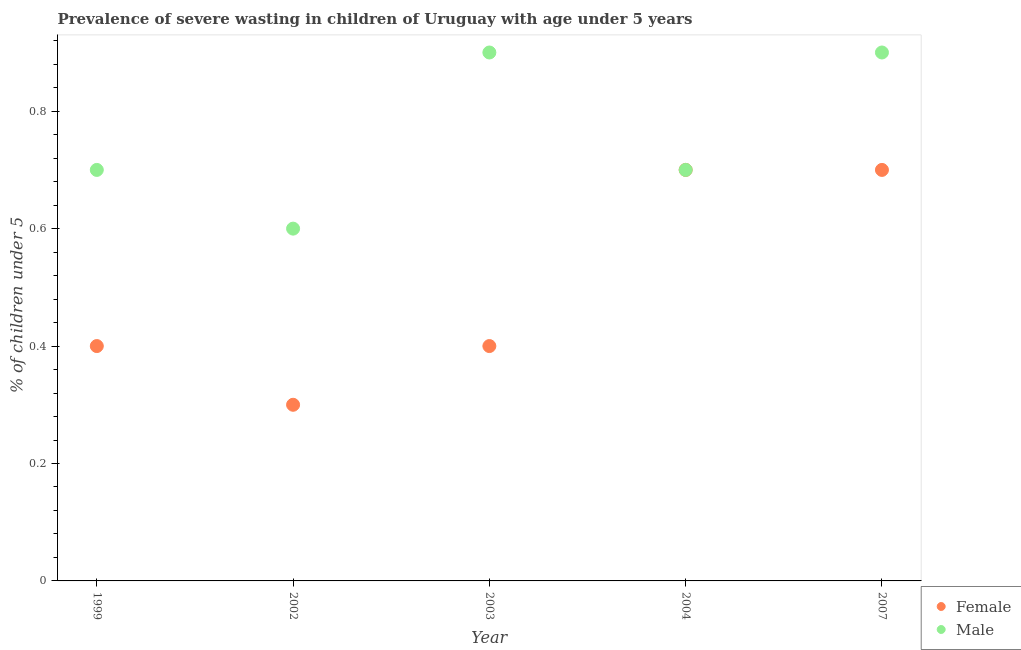What is the percentage of undernourished female children in 2007?
Your response must be concise. 0.7. Across all years, what is the maximum percentage of undernourished male children?
Your response must be concise. 0.9. Across all years, what is the minimum percentage of undernourished female children?
Give a very brief answer. 0.3. In which year was the percentage of undernourished male children maximum?
Provide a succinct answer. 2003. In which year was the percentage of undernourished male children minimum?
Your response must be concise. 2002. What is the total percentage of undernourished male children in the graph?
Your response must be concise. 3.8. What is the difference between the percentage of undernourished male children in 1999 and that in 2004?
Keep it short and to the point. 0. What is the difference between the percentage of undernourished female children in 2007 and the percentage of undernourished male children in 2004?
Make the answer very short. 0. What is the average percentage of undernourished male children per year?
Provide a short and direct response. 0.76. In the year 2007, what is the difference between the percentage of undernourished female children and percentage of undernourished male children?
Your answer should be very brief. -0.2. What is the ratio of the percentage of undernourished male children in 1999 to that in 2007?
Provide a short and direct response. 0.78. Is the percentage of undernourished female children in 1999 less than that in 2002?
Offer a very short reply. No. What is the difference between the highest and the lowest percentage of undernourished male children?
Your answer should be very brief. 0.3. In how many years, is the percentage of undernourished female children greater than the average percentage of undernourished female children taken over all years?
Make the answer very short. 2. Is the sum of the percentage of undernourished male children in 2002 and 2004 greater than the maximum percentage of undernourished female children across all years?
Keep it short and to the point. Yes. Does the percentage of undernourished female children monotonically increase over the years?
Provide a short and direct response. No. Is the percentage of undernourished female children strictly greater than the percentage of undernourished male children over the years?
Your answer should be compact. No. How many dotlines are there?
Offer a terse response. 2. Are the values on the major ticks of Y-axis written in scientific E-notation?
Your response must be concise. No. How are the legend labels stacked?
Make the answer very short. Vertical. What is the title of the graph?
Your response must be concise. Prevalence of severe wasting in children of Uruguay with age under 5 years. What is the label or title of the X-axis?
Offer a terse response. Year. What is the label or title of the Y-axis?
Keep it short and to the point.  % of children under 5. What is the  % of children under 5 of Female in 1999?
Offer a very short reply. 0.4. What is the  % of children under 5 of Male in 1999?
Offer a very short reply. 0.7. What is the  % of children under 5 of Female in 2002?
Keep it short and to the point. 0.3. What is the  % of children under 5 in Male in 2002?
Give a very brief answer. 0.6. What is the  % of children under 5 in Female in 2003?
Keep it short and to the point. 0.4. What is the  % of children under 5 in Male in 2003?
Give a very brief answer. 0.9. What is the  % of children under 5 in Female in 2004?
Keep it short and to the point. 0.7. What is the  % of children under 5 of Male in 2004?
Your answer should be compact. 0.7. What is the  % of children under 5 in Female in 2007?
Keep it short and to the point. 0.7. What is the  % of children under 5 of Male in 2007?
Make the answer very short. 0.9. Across all years, what is the maximum  % of children under 5 in Female?
Provide a short and direct response. 0.7. Across all years, what is the maximum  % of children under 5 in Male?
Your answer should be very brief. 0.9. Across all years, what is the minimum  % of children under 5 of Female?
Provide a short and direct response. 0.3. Across all years, what is the minimum  % of children under 5 of Male?
Keep it short and to the point. 0.6. What is the total  % of children under 5 of Male in the graph?
Your answer should be very brief. 3.8. What is the difference between the  % of children under 5 in Male in 1999 and that in 2003?
Provide a short and direct response. -0.2. What is the difference between the  % of children under 5 in Female in 1999 and that in 2004?
Offer a terse response. -0.3. What is the difference between the  % of children under 5 of Female in 1999 and that in 2007?
Offer a terse response. -0.3. What is the difference between the  % of children under 5 of Male in 1999 and that in 2007?
Give a very brief answer. -0.2. What is the difference between the  % of children under 5 of Female in 2002 and that in 2003?
Your answer should be compact. -0.1. What is the difference between the  % of children under 5 of Male in 2002 and that in 2003?
Provide a succinct answer. -0.3. What is the difference between the  % of children under 5 in Male in 2002 and that in 2004?
Provide a short and direct response. -0.1. What is the difference between the  % of children under 5 of Male in 2003 and that in 2004?
Offer a very short reply. 0.2. What is the difference between the  % of children under 5 in Female in 2004 and that in 2007?
Ensure brevity in your answer.  0. What is the difference between the  % of children under 5 of Female in 1999 and the  % of children under 5 of Male in 2004?
Provide a short and direct response. -0.3. What is the difference between the  % of children under 5 in Female in 1999 and the  % of children under 5 in Male in 2007?
Provide a succinct answer. -0.5. What is the difference between the  % of children under 5 in Female in 2003 and the  % of children under 5 in Male in 2007?
Provide a succinct answer. -0.5. What is the difference between the  % of children under 5 in Female in 2004 and the  % of children under 5 in Male in 2007?
Ensure brevity in your answer.  -0.2. What is the average  % of children under 5 in Male per year?
Ensure brevity in your answer.  0.76. In the year 2002, what is the difference between the  % of children under 5 of Female and  % of children under 5 of Male?
Provide a short and direct response. -0.3. In the year 2003, what is the difference between the  % of children under 5 in Female and  % of children under 5 in Male?
Give a very brief answer. -0.5. In the year 2004, what is the difference between the  % of children under 5 in Female and  % of children under 5 in Male?
Offer a very short reply. 0. What is the ratio of the  % of children under 5 of Female in 1999 to that in 2002?
Keep it short and to the point. 1.33. What is the ratio of the  % of children under 5 in Female in 1999 to that in 2003?
Make the answer very short. 1. What is the ratio of the  % of children under 5 of Male in 1999 to that in 2003?
Give a very brief answer. 0.78. What is the ratio of the  % of children under 5 in Female in 1999 to that in 2004?
Your answer should be compact. 0.57. What is the ratio of the  % of children under 5 in Male in 1999 to that in 2004?
Your answer should be very brief. 1. What is the ratio of the  % of children under 5 in Female in 1999 to that in 2007?
Provide a succinct answer. 0.57. What is the ratio of the  % of children under 5 in Female in 2002 to that in 2003?
Give a very brief answer. 0.75. What is the ratio of the  % of children under 5 of Male in 2002 to that in 2003?
Provide a short and direct response. 0.67. What is the ratio of the  % of children under 5 in Female in 2002 to that in 2004?
Keep it short and to the point. 0.43. What is the ratio of the  % of children under 5 of Male in 2002 to that in 2004?
Provide a succinct answer. 0.86. What is the ratio of the  % of children under 5 in Female in 2002 to that in 2007?
Provide a short and direct response. 0.43. What is the ratio of the  % of children under 5 of Male in 2002 to that in 2007?
Make the answer very short. 0.67. What is the ratio of the  % of children under 5 of Female in 2003 to that in 2004?
Keep it short and to the point. 0.57. What is the ratio of the  % of children under 5 of Male in 2003 to that in 2004?
Ensure brevity in your answer.  1.29. What is the ratio of the  % of children under 5 in Female in 2003 to that in 2007?
Give a very brief answer. 0.57. What is the ratio of the  % of children under 5 of Male in 2004 to that in 2007?
Ensure brevity in your answer.  0.78. What is the difference between the highest and the second highest  % of children under 5 in Male?
Offer a terse response. 0. What is the difference between the highest and the lowest  % of children under 5 in Female?
Keep it short and to the point. 0.4. What is the difference between the highest and the lowest  % of children under 5 of Male?
Your answer should be very brief. 0.3. 